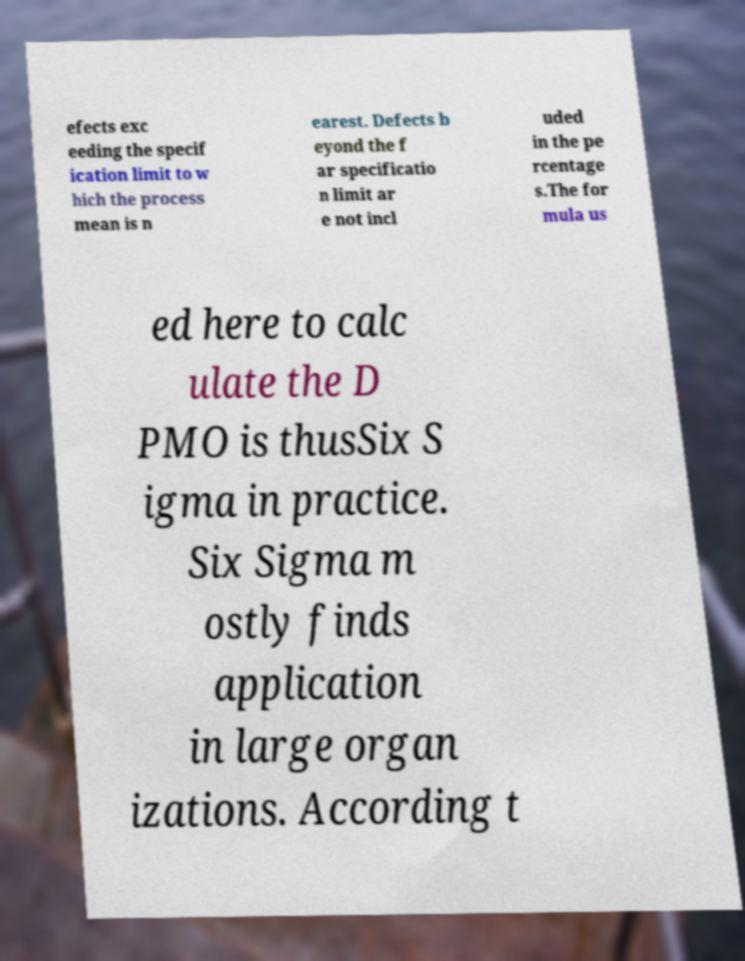Could you extract and type out the text from this image? efects exc eeding the specif ication limit to w hich the process mean is n earest. Defects b eyond the f ar specificatio n limit ar e not incl uded in the pe rcentage s.The for mula us ed here to calc ulate the D PMO is thusSix S igma in practice. Six Sigma m ostly finds application in large organ izations. According t 